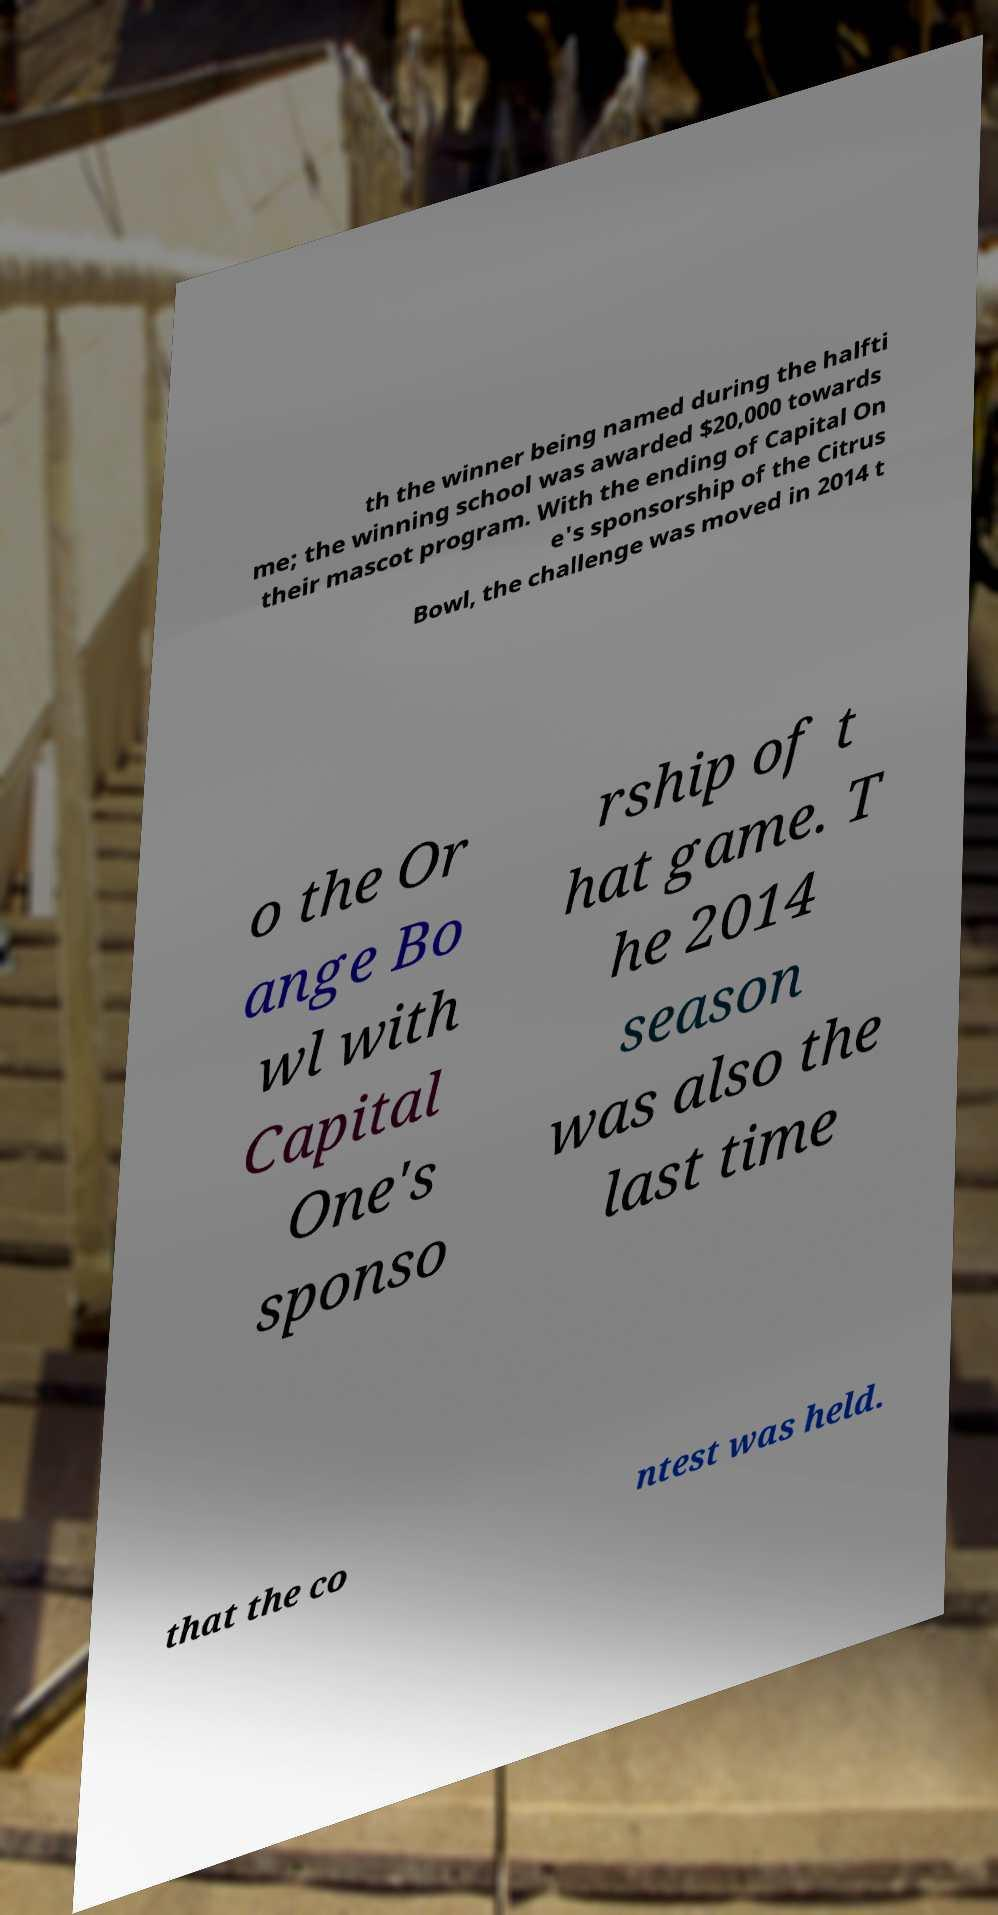Could you extract and type out the text from this image? th the winner being named during the halfti me; the winning school was awarded $20,000 towards their mascot program. With the ending of Capital On e's sponsorship of the Citrus Bowl, the challenge was moved in 2014 t o the Or ange Bo wl with Capital One's sponso rship of t hat game. T he 2014 season was also the last time that the co ntest was held. 